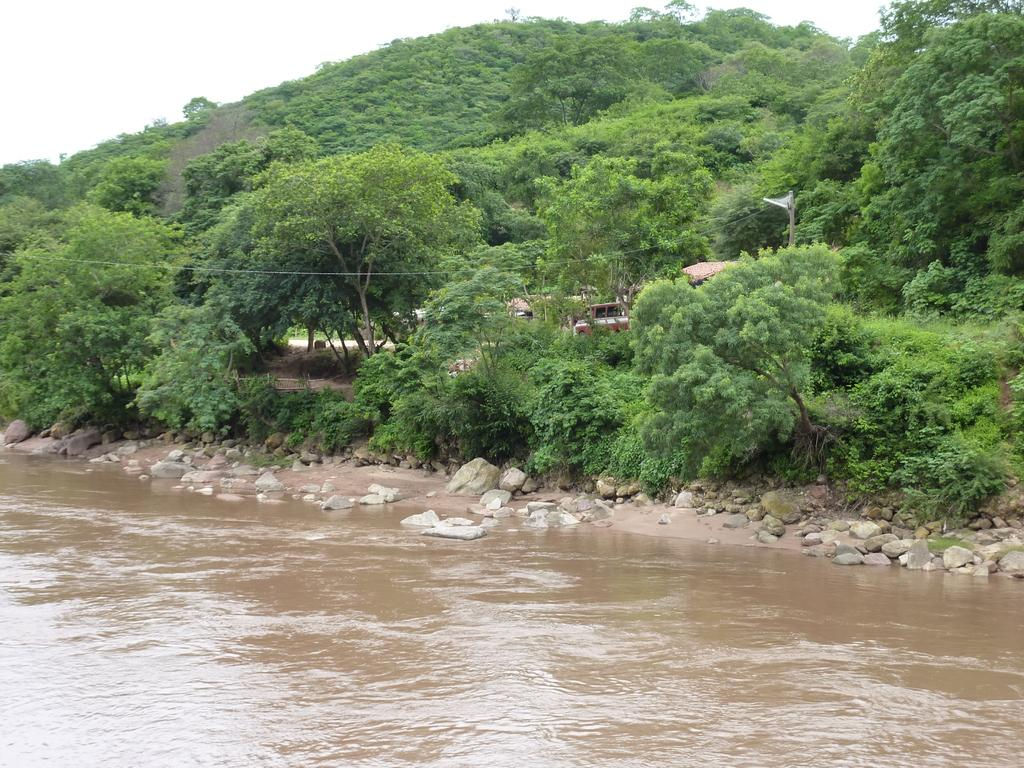What is the main element in the image? There is water in the image. What can be seen near the water? There is a tree beside the water. What else is present in the image? There is an object and a pole with wires in the image. What is visible at the top of the image? The sky is visible at the top of the image. Can you see any slaves or veils in the image? No, there are no slaves or veils present in the image. Are there any fangs visible in the image? No, there are no fangs visible in the image. 